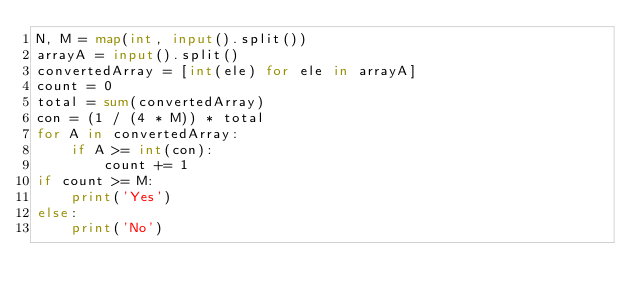Convert code to text. <code><loc_0><loc_0><loc_500><loc_500><_Python_>N, M = map(int, input().split())
arrayA = input().split()
convertedArray = [int(ele) for ele in arrayA]
count = 0
total = sum(convertedArray)
con = (1 / (4 * M)) * total
for A in convertedArray:
    if A >= int(con):
        count += 1
if count >= M:
    print('Yes')
else:
    print('No')</code> 